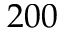<formula> <loc_0><loc_0><loc_500><loc_500>2 0 0</formula> 